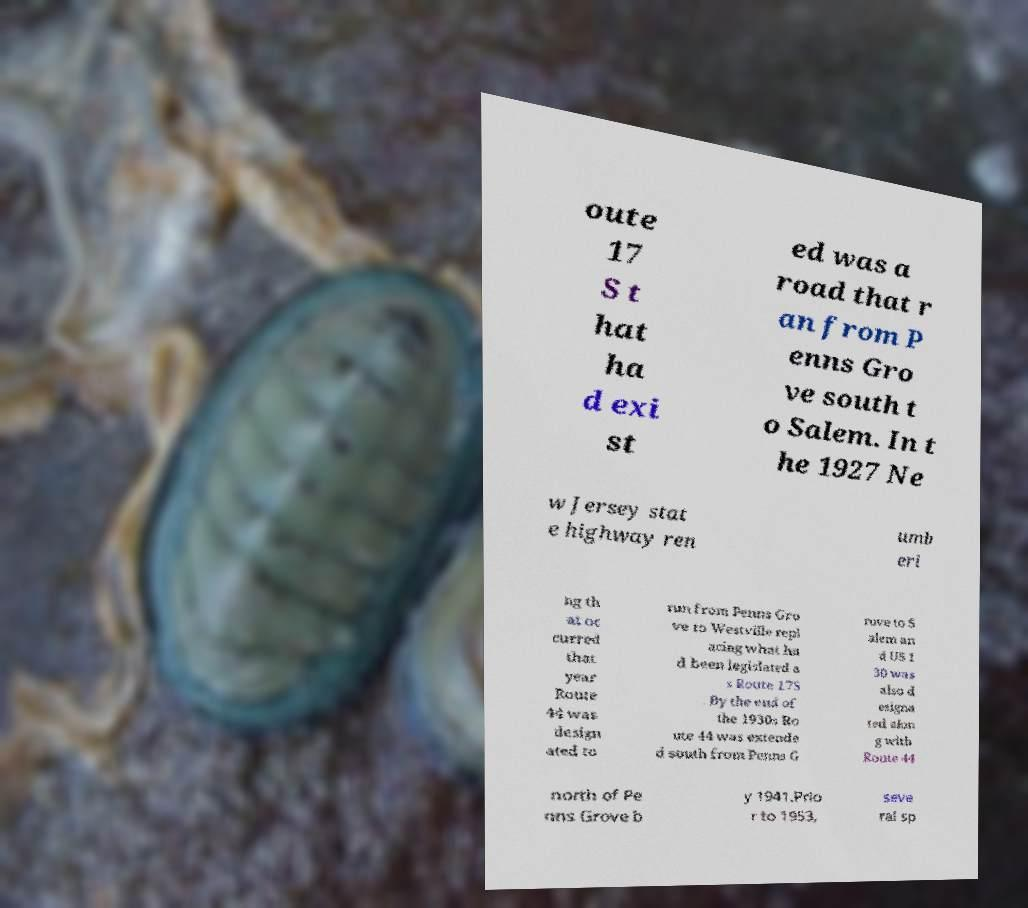Can you read and provide the text displayed in the image?This photo seems to have some interesting text. Can you extract and type it out for me? oute 17 S t hat ha d exi st ed was a road that r an from P enns Gro ve south t o Salem. In t he 1927 Ne w Jersey stat e highway ren umb eri ng th at oc curred that year Route 44 was design ated to run from Penns Gro ve to Westville repl acing what ha d been legislated a s Route 17S . By the end of the 1930s Ro ute 44 was extende d south from Penns G rove to S alem an d US 1 30 was also d esigna ted alon g with Route 44 north of Pe nns Grove b y 1941.Prio r to 1953, seve ral sp 